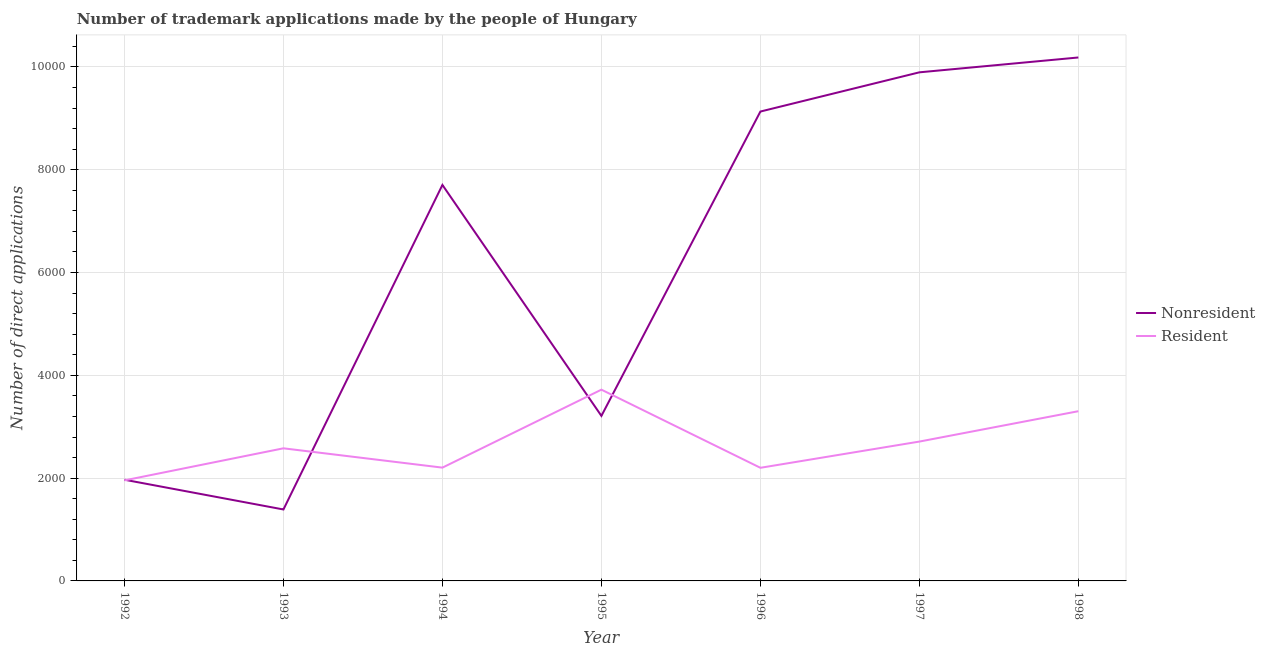Does the line corresponding to number of trademark applications made by residents intersect with the line corresponding to number of trademark applications made by non residents?
Make the answer very short. Yes. What is the number of trademark applications made by residents in 1997?
Your answer should be very brief. 2711. Across all years, what is the maximum number of trademark applications made by residents?
Make the answer very short. 3721. Across all years, what is the minimum number of trademark applications made by non residents?
Offer a terse response. 1390. In which year was the number of trademark applications made by residents maximum?
Make the answer very short. 1995. In which year was the number of trademark applications made by non residents minimum?
Give a very brief answer. 1993. What is the total number of trademark applications made by non residents in the graph?
Keep it short and to the point. 4.35e+04. What is the difference between the number of trademark applications made by residents in 1992 and that in 1995?
Your answer should be very brief. -1765. What is the difference between the number of trademark applications made by residents in 1998 and the number of trademark applications made by non residents in 1995?
Provide a succinct answer. 91. What is the average number of trademark applications made by residents per year?
Your answer should be very brief. 2667.86. In the year 1994, what is the difference between the number of trademark applications made by residents and number of trademark applications made by non residents?
Give a very brief answer. -5500. What is the ratio of the number of trademark applications made by residents in 1996 to that in 1997?
Offer a terse response. 0.81. What is the difference between the highest and the second highest number of trademark applications made by residents?
Ensure brevity in your answer.  419. What is the difference between the highest and the lowest number of trademark applications made by residents?
Provide a short and direct response. 1765. In how many years, is the number of trademark applications made by residents greater than the average number of trademark applications made by residents taken over all years?
Give a very brief answer. 3. Is the sum of the number of trademark applications made by non residents in 1993 and 1994 greater than the maximum number of trademark applications made by residents across all years?
Ensure brevity in your answer.  Yes. Does the number of trademark applications made by non residents monotonically increase over the years?
Make the answer very short. No. Is the number of trademark applications made by non residents strictly greater than the number of trademark applications made by residents over the years?
Provide a succinct answer. No. How many lines are there?
Ensure brevity in your answer.  2. How many years are there in the graph?
Offer a very short reply. 7. Does the graph contain grids?
Make the answer very short. Yes. How many legend labels are there?
Your answer should be very brief. 2. How are the legend labels stacked?
Your response must be concise. Vertical. What is the title of the graph?
Offer a terse response. Number of trademark applications made by the people of Hungary. Does "Young" appear as one of the legend labels in the graph?
Your answer should be very brief. No. What is the label or title of the X-axis?
Keep it short and to the point. Year. What is the label or title of the Y-axis?
Make the answer very short. Number of direct applications. What is the Number of direct applications of Nonresident in 1992?
Make the answer very short. 1969. What is the Number of direct applications of Resident in 1992?
Make the answer very short. 1956. What is the Number of direct applications in Nonresident in 1993?
Your response must be concise. 1390. What is the Number of direct applications in Resident in 1993?
Give a very brief answer. 2580. What is the Number of direct applications in Nonresident in 1994?
Make the answer very short. 7704. What is the Number of direct applications in Resident in 1994?
Your answer should be very brief. 2204. What is the Number of direct applications in Nonresident in 1995?
Your response must be concise. 3211. What is the Number of direct applications in Resident in 1995?
Keep it short and to the point. 3721. What is the Number of direct applications of Nonresident in 1996?
Offer a very short reply. 9132. What is the Number of direct applications of Resident in 1996?
Ensure brevity in your answer.  2201. What is the Number of direct applications in Nonresident in 1997?
Keep it short and to the point. 9895. What is the Number of direct applications of Resident in 1997?
Your answer should be compact. 2711. What is the Number of direct applications in Nonresident in 1998?
Ensure brevity in your answer.  1.02e+04. What is the Number of direct applications in Resident in 1998?
Ensure brevity in your answer.  3302. Across all years, what is the maximum Number of direct applications of Nonresident?
Ensure brevity in your answer.  1.02e+04. Across all years, what is the maximum Number of direct applications in Resident?
Your answer should be very brief. 3721. Across all years, what is the minimum Number of direct applications in Nonresident?
Your response must be concise. 1390. Across all years, what is the minimum Number of direct applications in Resident?
Offer a terse response. 1956. What is the total Number of direct applications in Nonresident in the graph?
Ensure brevity in your answer.  4.35e+04. What is the total Number of direct applications in Resident in the graph?
Keep it short and to the point. 1.87e+04. What is the difference between the Number of direct applications of Nonresident in 1992 and that in 1993?
Offer a terse response. 579. What is the difference between the Number of direct applications in Resident in 1992 and that in 1993?
Your answer should be compact. -624. What is the difference between the Number of direct applications in Nonresident in 1992 and that in 1994?
Your answer should be very brief. -5735. What is the difference between the Number of direct applications of Resident in 1992 and that in 1994?
Offer a very short reply. -248. What is the difference between the Number of direct applications in Nonresident in 1992 and that in 1995?
Offer a terse response. -1242. What is the difference between the Number of direct applications of Resident in 1992 and that in 1995?
Your answer should be very brief. -1765. What is the difference between the Number of direct applications of Nonresident in 1992 and that in 1996?
Provide a succinct answer. -7163. What is the difference between the Number of direct applications of Resident in 1992 and that in 1996?
Provide a succinct answer. -245. What is the difference between the Number of direct applications in Nonresident in 1992 and that in 1997?
Your response must be concise. -7926. What is the difference between the Number of direct applications in Resident in 1992 and that in 1997?
Keep it short and to the point. -755. What is the difference between the Number of direct applications in Nonresident in 1992 and that in 1998?
Ensure brevity in your answer.  -8215. What is the difference between the Number of direct applications of Resident in 1992 and that in 1998?
Your response must be concise. -1346. What is the difference between the Number of direct applications of Nonresident in 1993 and that in 1994?
Keep it short and to the point. -6314. What is the difference between the Number of direct applications of Resident in 1993 and that in 1994?
Provide a succinct answer. 376. What is the difference between the Number of direct applications in Nonresident in 1993 and that in 1995?
Offer a terse response. -1821. What is the difference between the Number of direct applications in Resident in 1993 and that in 1995?
Your answer should be compact. -1141. What is the difference between the Number of direct applications in Nonresident in 1993 and that in 1996?
Keep it short and to the point. -7742. What is the difference between the Number of direct applications in Resident in 1993 and that in 1996?
Offer a very short reply. 379. What is the difference between the Number of direct applications in Nonresident in 1993 and that in 1997?
Your response must be concise. -8505. What is the difference between the Number of direct applications of Resident in 1993 and that in 1997?
Give a very brief answer. -131. What is the difference between the Number of direct applications of Nonresident in 1993 and that in 1998?
Ensure brevity in your answer.  -8794. What is the difference between the Number of direct applications in Resident in 1993 and that in 1998?
Offer a very short reply. -722. What is the difference between the Number of direct applications of Nonresident in 1994 and that in 1995?
Give a very brief answer. 4493. What is the difference between the Number of direct applications in Resident in 1994 and that in 1995?
Give a very brief answer. -1517. What is the difference between the Number of direct applications in Nonresident in 1994 and that in 1996?
Offer a terse response. -1428. What is the difference between the Number of direct applications in Nonresident in 1994 and that in 1997?
Offer a terse response. -2191. What is the difference between the Number of direct applications of Resident in 1994 and that in 1997?
Your answer should be compact. -507. What is the difference between the Number of direct applications of Nonresident in 1994 and that in 1998?
Provide a succinct answer. -2480. What is the difference between the Number of direct applications in Resident in 1994 and that in 1998?
Your answer should be very brief. -1098. What is the difference between the Number of direct applications of Nonresident in 1995 and that in 1996?
Provide a short and direct response. -5921. What is the difference between the Number of direct applications of Resident in 1995 and that in 1996?
Provide a succinct answer. 1520. What is the difference between the Number of direct applications of Nonresident in 1995 and that in 1997?
Offer a terse response. -6684. What is the difference between the Number of direct applications in Resident in 1995 and that in 1997?
Make the answer very short. 1010. What is the difference between the Number of direct applications of Nonresident in 1995 and that in 1998?
Give a very brief answer. -6973. What is the difference between the Number of direct applications of Resident in 1995 and that in 1998?
Your answer should be compact. 419. What is the difference between the Number of direct applications in Nonresident in 1996 and that in 1997?
Keep it short and to the point. -763. What is the difference between the Number of direct applications in Resident in 1996 and that in 1997?
Give a very brief answer. -510. What is the difference between the Number of direct applications in Nonresident in 1996 and that in 1998?
Ensure brevity in your answer.  -1052. What is the difference between the Number of direct applications of Resident in 1996 and that in 1998?
Provide a short and direct response. -1101. What is the difference between the Number of direct applications of Nonresident in 1997 and that in 1998?
Ensure brevity in your answer.  -289. What is the difference between the Number of direct applications in Resident in 1997 and that in 1998?
Give a very brief answer. -591. What is the difference between the Number of direct applications of Nonresident in 1992 and the Number of direct applications of Resident in 1993?
Offer a very short reply. -611. What is the difference between the Number of direct applications in Nonresident in 1992 and the Number of direct applications in Resident in 1994?
Keep it short and to the point. -235. What is the difference between the Number of direct applications of Nonresident in 1992 and the Number of direct applications of Resident in 1995?
Offer a terse response. -1752. What is the difference between the Number of direct applications of Nonresident in 1992 and the Number of direct applications of Resident in 1996?
Your response must be concise. -232. What is the difference between the Number of direct applications of Nonresident in 1992 and the Number of direct applications of Resident in 1997?
Ensure brevity in your answer.  -742. What is the difference between the Number of direct applications of Nonresident in 1992 and the Number of direct applications of Resident in 1998?
Your answer should be compact. -1333. What is the difference between the Number of direct applications of Nonresident in 1993 and the Number of direct applications of Resident in 1994?
Your response must be concise. -814. What is the difference between the Number of direct applications of Nonresident in 1993 and the Number of direct applications of Resident in 1995?
Ensure brevity in your answer.  -2331. What is the difference between the Number of direct applications of Nonresident in 1993 and the Number of direct applications of Resident in 1996?
Your answer should be very brief. -811. What is the difference between the Number of direct applications in Nonresident in 1993 and the Number of direct applications in Resident in 1997?
Your response must be concise. -1321. What is the difference between the Number of direct applications in Nonresident in 1993 and the Number of direct applications in Resident in 1998?
Your answer should be very brief. -1912. What is the difference between the Number of direct applications in Nonresident in 1994 and the Number of direct applications in Resident in 1995?
Provide a succinct answer. 3983. What is the difference between the Number of direct applications of Nonresident in 1994 and the Number of direct applications of Resident in 1996?
Your answer should be compact. 5503. What is the difference between the Number of direct applications in Nonresident in 1994 and the Number of direct applications in Resident in 1997?
Provide a succinct answer. 4993. What is the difference between the Number of direct applications of Nonresident in 1994 and the Number of direct applications of Resident in 1998?
Offer a terse response. 4402. What is the difference between the Number of direct applications in Nonresident in 1995 and the Number of direct applications in Resident in 1996?
Offer a terse response. 1010. What is the difference between the Number of direct applications in Nonresident in 1995 and the Number of direct applications in Resident in 1997?
Offer a very short reply. 500. What is the difference between the Number of direct applications of Nonresident in 1995 and the Number of direct applications of Resident in 1998?
Ensure brevity in your answer.  -91. What is the difference between the Number of direct applications in Nonresident in 1996 and the Number of direct applications in Resident in 1997?
Ensure brevity in your answer.  6421. What is the difference between the Number of direct applications of Nonresident in 1996 and the Number of direct applications of Resident in 1998?
Offer a very short reply. 5830. What is the difference between the Number of direct applications of Nonresident in 1997 and the Number of direct applications of Resident in 1998?
Offer a very short reply. 6593. What is the average Number of direct applications in Nonresident per year?
Ensure brevity in your answer.  6212.14. What is the average Number of direct applications in Resident per year?
Make the answer very short. 2667.86. In the year 1993, what is the difference between the Number of direct applications of Nonresident and Number of direct applications of Resident?
Your response must be concise. -1190. In the year 1994, what is the difference between the Number of direct applications of Nonresident and Number of direct applications of Resident?
Provide a succinct answer. 5500. In the year 1995, what is the difference between the Number of direct applications of Nonresident and Number of direct applications of Resident?
Offer a terse response. -510. In the year 1996, what is the difference between the Number of direct applications of Nonresident and Number of direct applications of Resident?
Provide a succinct answer. 6931. In the year 1997, what is the difference between the Number of direct applications of Nonresident and Number of direct applications of Resident?
Offer a terse response. 7184. In the year 1998, what is the difference between the Number of direct applications of Nonresident and Number of direct applications of Resident?
Keep it short and to the point. 6882. What is the ratio of the Number of direct applications in Nonresident in 1992 to that in 1993?
Offer a terse response. 1.42. What is the ratio of the Number of direct applications of Resident in 1992 to that in 1993?
Provide a short and direct response. 0.76. What is the ratio of the Number of direct applications of Nonresident in 1992 to that in 1994?
Offer a terse response. 0.26. What is the ratio of the Number of direct applications of Resident in 1992 to that in 1994?
Your answer should be very brief. 0.89. What is the ratio of the Number of direct applications in Nonresident in 1992 to that in 1995?
Make the answer very short. 0.61. What is the ratio of the Number of direct applications of Resident in 1992 to that in 1995?
Give a very brief answer. 0.53. What is the ratio of the Number of direct applications of Nonresident in 1992 to that in 1996?
Your response must be concise. 0.22. What is the ratio of the Number of direct applications in Resident in 1992 to that in 1996?
Give a very brief answer. 0.89. What is the ratio of the Number of direct applications of Nonresident in 1992 to that in 1997?
Ensure brevity in your answer.  0.2. What is the ratio of the Number of direct applications of Resident in 1992 to that in 1997?
Give a very brief answer. 0.72. What is the ratio of the Number of direct applications of Nonresident in 1992 to that in 1998?
Your answer should be very brief. 0.19. What is the ratio of the Number of direct applications of Resident in 1992 to that in 1998?
Make the answer very short. 0.59. What is the ratio of the Number of direct applications in Nonresident in 1993 to that in 1994?
Make the answer very short. 0.18. What is the ratio of the Number of direct applications in Resident in 1993 to that in 1994?
Keep it short and to the point. 1.17. What is the ratio of the Number of direct applications in Nonresident in 1993 to that in 1995?
Your answer should be compact. 0.43. What is the ratio of the Number of direct applications of Resident in 1993 to that in 1995?
Your answer should be very brief. 0.69. What is the ratio of the Number of direct applications of Nonresident in 1993 to that in 1996?
Your answer should be compact. 0.15. What is the ratio of the Number of direct applications of Resident in 1993 to that in 1996?
Keep it short and to the point. 1.17. What is the ratio of the Number of direct applications in Nonresident in 1993 to that in 1997?
Provide a short and direct response. 0.14. What is the ratio of the Number of direct applications of Resident in 1993 to that in 1997?
Offer a terse response. 0.95. What is the ratio of the Number of direct applications of Nonresident in 1993 to that in 1998?
Give a very brief answer. 0.14. What is the ratio of the Number of direct applications of Resident in 1993 to that in 1998?
Your answer should be compact. 0.78. What is the ratio of the Number of direct applications in Nonresident in 1994 to that in 1995?
Your answer should be compact. 2.4. What is the ratio of the Number of direct applications in Resident in 1994 to that in 1995?
Your answer should be very brief. 0.59. What is the ratio of the Number of direct applications in Nonresident in 1994 to that in 1996?
Your response must be concise. 0.84. What is the ratio of the Number of direct applications in Resident in 1994 to that in 1996?
Make the answer very short. 1. What is the ratio of the Number of direct applications of Nonresident in 1994 to that in 1997?
Offer a very short reply. 0.78. What is the ratio of the Number of direct applications in Resident in 1994 to that in 1997?
Provide a short and direct response. 0.81. What is the ratio of the Number of direct applications of Nonresident in 1994 to that in 1998?
Offer a very short reply. 0.76. What is the ratio of the Number of direct applications in Resident in 1994 to that in 1998?
Give a very brief answer. 0.67. What is the ratio of the Number of direct applications in Nonresident in 1995 to that in 1996?
Offer a terse response. 0.35. What is the ratio of the Number of direct applications in Resident in 1995 to that in 1996?
Your response must be concise. 1.69. What is the ratio of the Number of direct applications of Nonresident in 1995 to that in 1997?
Your response must be concise. 0.32. What is the ratio of the Number of direct applications of Resident in 1995 to that in 1997?
Make the answer very short. 1.37. What is the ratio of the Number of direct applications in Nonresident in 1995 to that in 1998?
Your answer should be compact. 0.32. What is the ratio of the Number of direct applications in Resident in 1995 to that in 1998?
Make the answer very short. 1.13. What is the ratio of the Number of direct applications in Nonresident in 1996 to that in 1997?
Ensure brevity in your answer.  0.92. What is the ratio of the Number of direct applications of Resident in 1996 to that in 1997?
Your answer should be very brief. 0.81. What is the ratio of the Number of direct applications in Nonresident in 1996 to that in 1998?
Make the answer very short. 0.9. What is the ratio of the Number of direct applications in Resident in 1996 to that in 1998?
Make the answer very short. 0.67. What is the ratio of the Number of direct applications in Nonresident in 1997 to that in 1998?
Your answer should be very brief. 0.97. What is the ratio of the Number of direct applications in Resident in 1997 to that in 1998?
Provide a short and direct response. 0.82. What is the difference between the highest and the second highest Number of direct applications of Nonresident?
Make the answer very short. 289. What is the difference between the highest and the second highest Number of direct applications in Resident?
Provide a short and direct response. 419. What is the difference between the highest and the lowest Number of direct applications in Nonresident?
Your answer should be very brief. 8794. What is the difference between the highest and the lowest Number of direct applications of Resident?
Your response must be concise. 1765. 